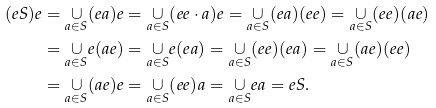<formula> <loc_0><loc_0><loc_500><loc_500>( e S ) e & = \underset { a \in S } { \cup } ( e a ) e = \underset { a \in S } { \cup } ( e e \cdot a ) e = \underset { a \in S } { \cup } ( e a ) ( e e ) = \underset { a \in S } { \cup } ( e e ) ( a e ) \\ & = \underset { a \in S } { \cup } e ( a e ) = \underset { a \in S } { \cup } e ( e a ) = \underset { a \in S } { \cup } ( e e ) ( e a ) = \underset { a \in S } { \cup } ( a e ) ( e e ) \\ & = \underset { a \in S } { \cup } ( a e ) e = \underset { a \in S } { \cup } ( e e ) a = \underset { a \in S } { \cup } e a = e S .</formula> 